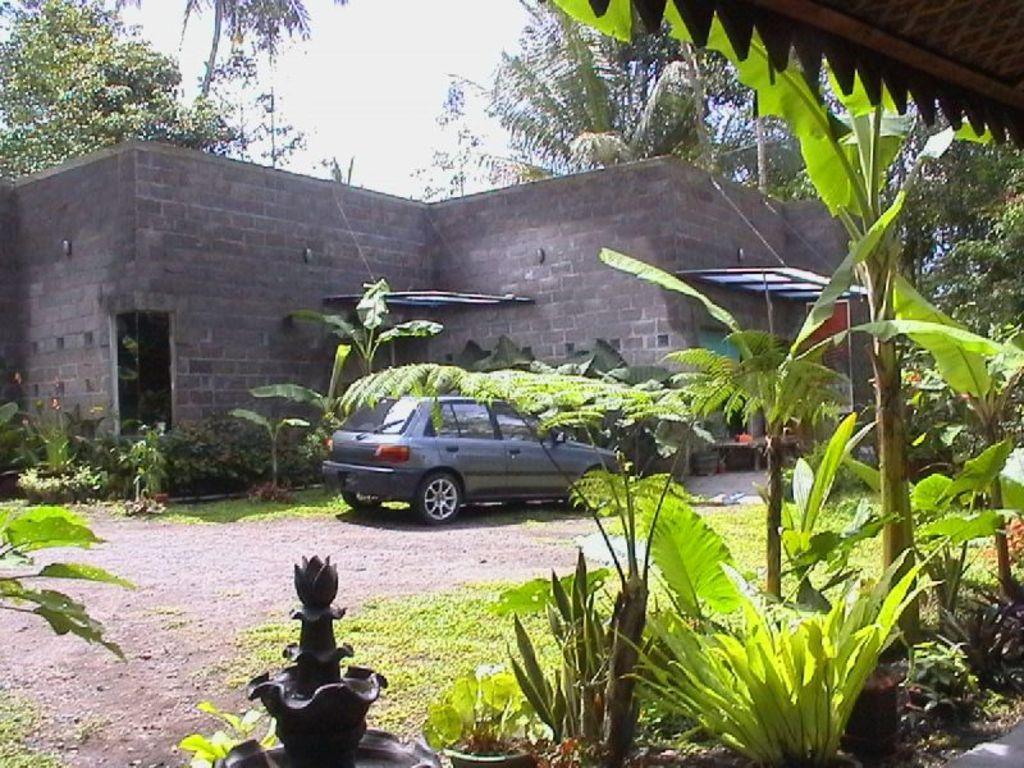How would you summarize this image in a sentence or two? This picture shows a building and we see trees and few plants and a car parked and we see a cloudy sky and grass on the ground. 